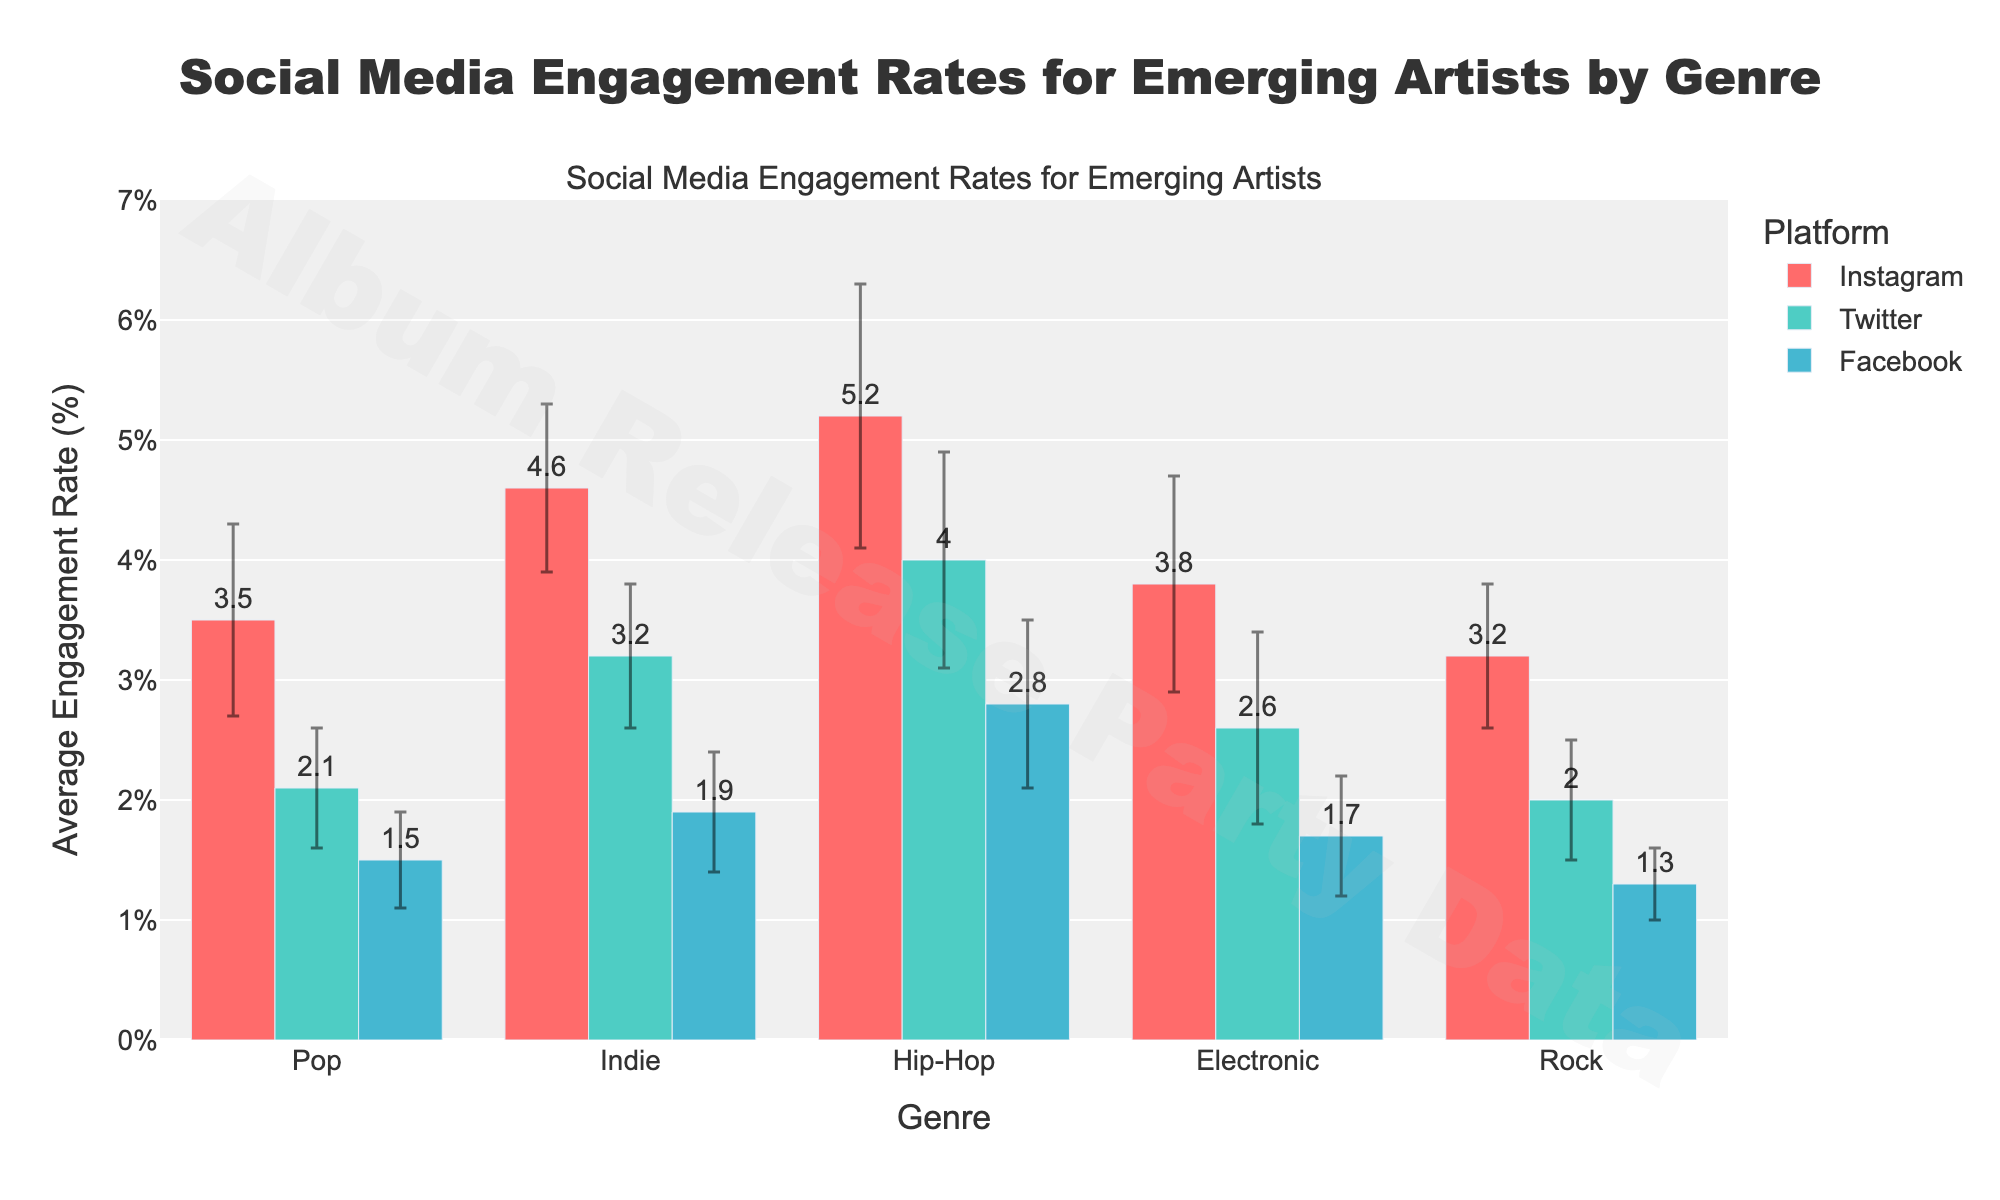What's the average engagement rate for Pop on Instagram? Look at the bar representing Pop on the Instagram platform. The value is indicated as 3.5.
Answer: 3.5 Which genre has the highest Instagram engagement rate? Compare all the bars for Instagram engagement rates across different genres. Hip-Hop has the highest bar with a rate of 5.2.
Answer: Hip-Hop What's the difference in average engagement rate between Indie and Rock genres on Twitter? Look at the bars for Indie and Rock on Twitter. Indie has a rate of 3.2, and Rock has a rate of 2. The difference is 3.2 - 2.
Answer: 1.2 Which platform shows the most varied engagement rates for the Hip-Hop genre? Check the error bars for Hip-Hop across all platforms. The largest error bar appears on Instagram with a standard deviation of 1.1.
Answer: Instagram How does the Facebook engagement rate of Electronic compare to that of Rock? Compare the bars for Electronic and Rock on Facebook. Electronic's engagement rate is 1.7, while Rock's is 1.3.
Answer: Electronic is higher What is the range of average engagement rates on Instagram? The highest engagement rate on Instagram is for Hip-Hop at 5.2, and the lowest is for Rock at 3.2. The range is 5.2 - 3.2.
Answer: 2.0 What's the combined average engagement rate for the Pop genre across all three platforms? Add the average engagement rates for Pop on Instagram, Twitter, and Facebook: 3.5 + 2.1 + 1.5 = 7.1.
Answer: 7.1 Which genre has the most consistent engagement rates across all platforms? Look at the error bars; the genre with the smallest and most uniform error bars across all platforms is Rock.
Answer: Rock What's the average standard deviation across platforms for the Electronic genre? Add the standard deviations for Electronic on all platforms: 0.9 (Instagram) + 0.8 (Twitter) + 0.5 (Facebook) = 2.2. The average is 2.2 / 3.
Answer: 0.73 How many genres have a higher engagement rate on Instagram than Twitter? Compare Instagram and Twitter bars for each genre. Pop, Indie, Hip-Hop, and Electronic have higher engagement rates on Instagram than on Twitter.
Answer: 4 genres 